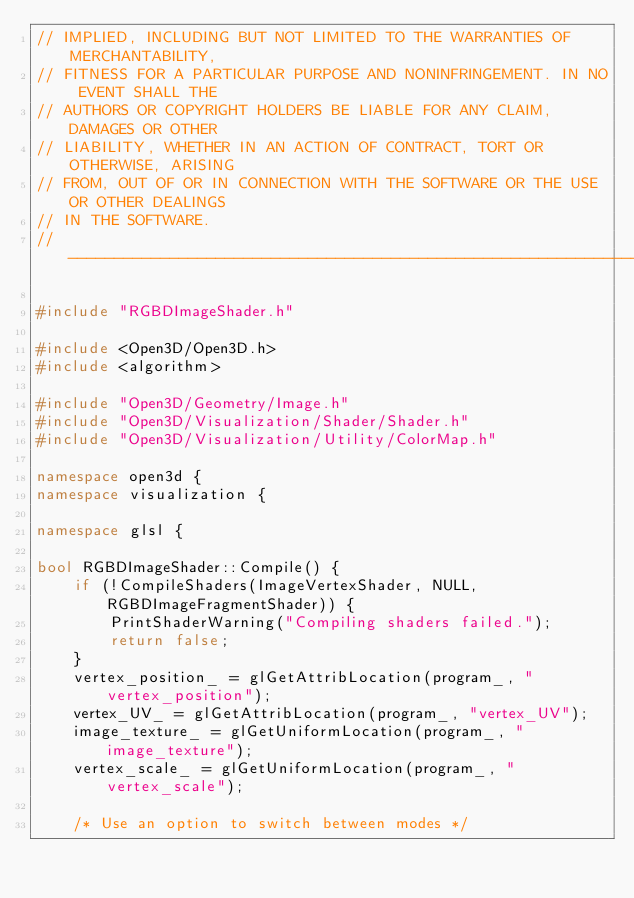<code> <loc_0><loc_0><loc_500><loc_500><_C++_>// IMPLIED, INCLUDING BUT NOT LIMITED TO THE WARRANTIES OF MERCHANTABILITY,
// FITNESS FOR A PARTICULAR PURPOSE AND NONINFRINGEMENT. IN NO EVENT SHALL THE
// AUTHORS OR COPYRIGHT HOLDERS BE LIABLE FOR ANY CLAIM, DAMAGES OR OTHER
// LIABILITY, WHETHER IN AN ACTION OF CONTRACT, TORT OR OTHERWISE, ARISING
// FROM, OUT OF OR IN CONNECTION WITH THE SOFTWARE OR THE USE OR OTHER DEALINGS
// IN THE SOFTWARE.
// ----------------------------------------------------------------------------

#include "RGBDImageShader.h"

#include <Open3D/Open3D.h>
#include <algorithm>

#include "Open3D/Geometry/Image.h"
#include "Open3D/Visualization/Shader/Shader.h"
#include "Open3D/Visualization/Utility/ColorMap.h"

namespace open3d {
namespace visualization {

namespace glsl {

bool RGBDImageShader::Compile() {
    if (!CompileShaders(ImageVertexShader, NULL, RGBDImageFragmentShader)) {
        PrintShaderWarning("Compiling shaders failed.");
        return false;
    }
    vertex_position_ = glGetAttribLocation(program_, "vertex_position");
    vertex_UV_ = glGetAttribLocation(program_, "vertex_UV");
    image_texture_ = glGetUniformLocation(program_, "image_texture");
    vertex_scale_ = glGetUniformLocation(program_, "vertex_scale");

    /* Use an option to switch between modes */</code> 